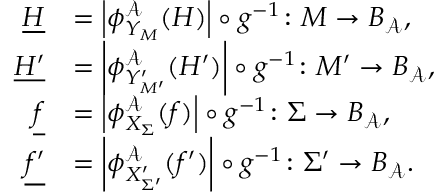Convert formula to latex. <formula><loc_0><loc_0><loc_500><loc_500>\begin{array} { r l } { \underline { H } } & { = \left | \phi _ { Y _ { M } } ^ { \mathcal { A } } ( H ) \right | \circ g ^ { - 1 } \colon M \to B _ { \mathcal { A } } , } \\ { \underline { { H ^ { \prime } } } } & { = \left | \phi _ { Y _ { M ^ { \prime } } ^ { \prime } } ^ { \mathcal { A } } ( H ^ { \prime } ) \right | \circ g ^ { - 1 } \colon M ^ { \prime } \to B _ { \mathcal { A } } , } \\ { \underline { f } } & { = \left | \phi _ { X _ { \Sigma } } ^ { \mathcal { A } } ( f ) \right | \circ g ^ { - 1 } \colon \Sigma \to B _ { \mathcal { A } } , } \\ { \underline { { f ^ { \prime } } } } & { = \left | \phi _ { X _ { \Sigma ^ { \prime } } ^ { \prime } } ^ { \mathcal { A } } ( f ^ { \prime } ) \right | \circ g ^ { - 1 } \colon \Sigma ^ { \prime } \to B _ { \mathcal { A } } . } \end{array}</formula> 